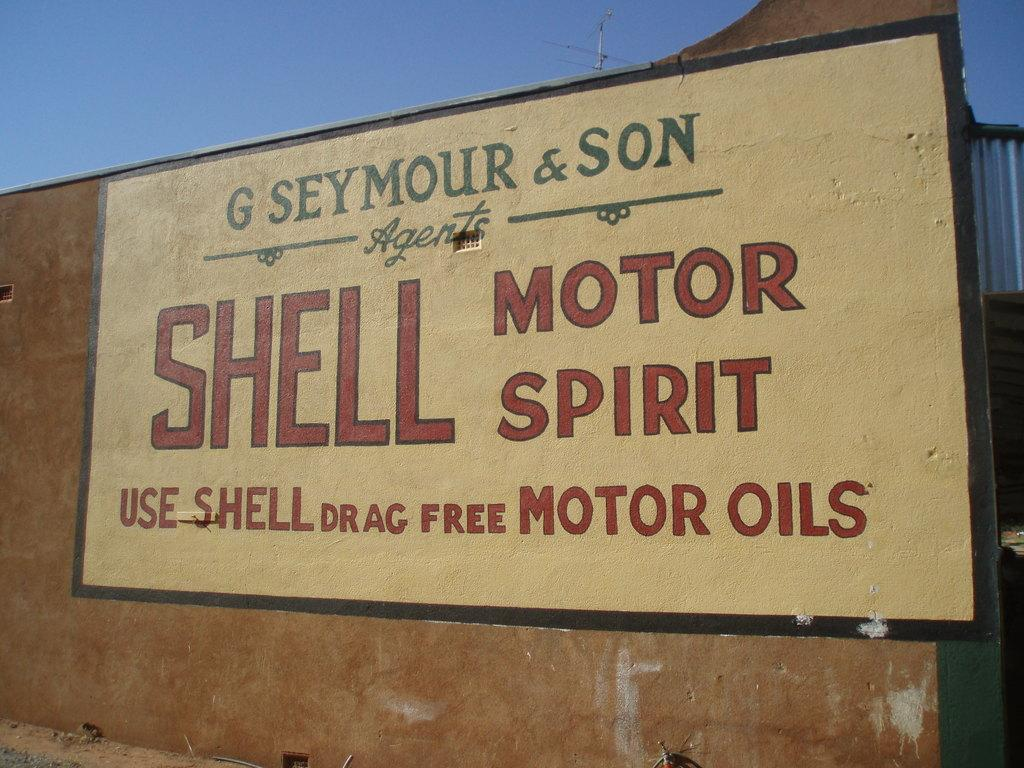What is the main structure visible in the image? There is a wall in the image. What is written or painted on the wall? There is text painted on the wall. What can be seen in the sky in the image? The sky is visible at the top of the image. What is located behind the wall in the image? There is an electric pole behind the wall in the image. How many women are riding the shape in the image? There is no shape or women present in the image. 